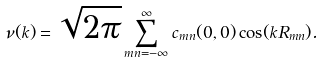Convert formula to latex. <formula><loc_0><loc_0><loc_500><loc_500>\nu ( { k } ) = \sqrt { 2 \pi } \sum _ { m n = - \infty } ^ { \infty } c _ { m n } ( 0 , 0 ) \cos ( { k } { R } _ { m n } ) .</formula> 